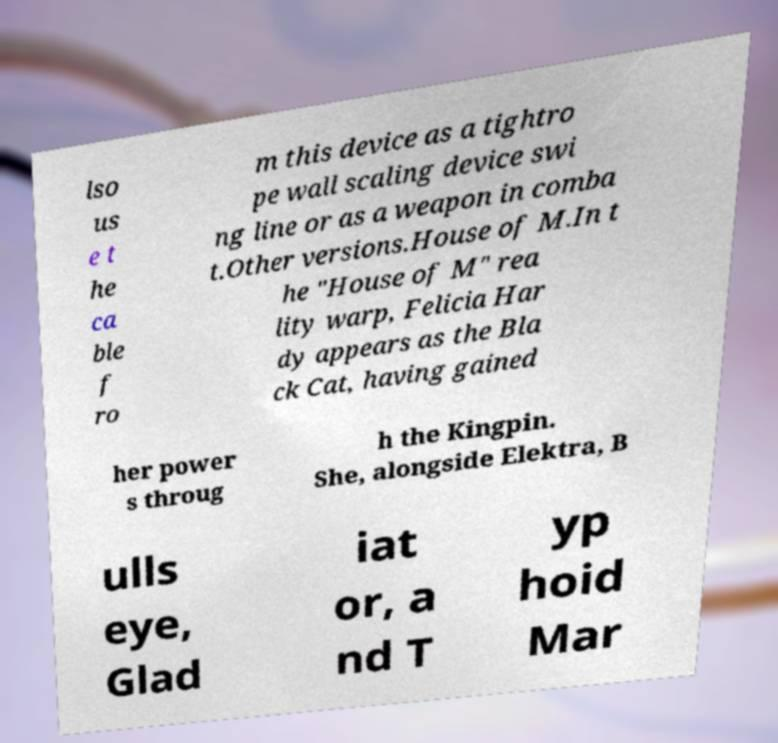What messages or text are displayed in this image? I need them in a readable, typed format. lso us e t he ca ble f ro m this device as a tightro pe wall scaling device swi ng line or as a weapon in comba t.Other versions.House of M.In t he "House of M" rea lity warp, Felicia Har dy appears as the Bla ck Cat, having gained her power s throug h the Kingpin. She, alongside Elektra, B ulls eye, Glad iat or, a nd T yp hoid Mar 